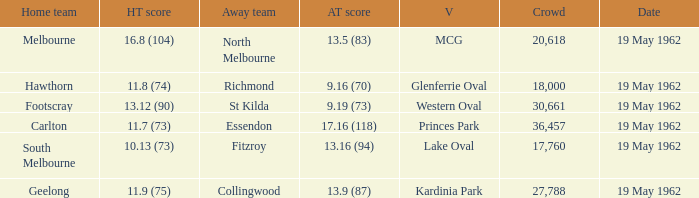What day is the western oval event taking place? 19 May 1962. 